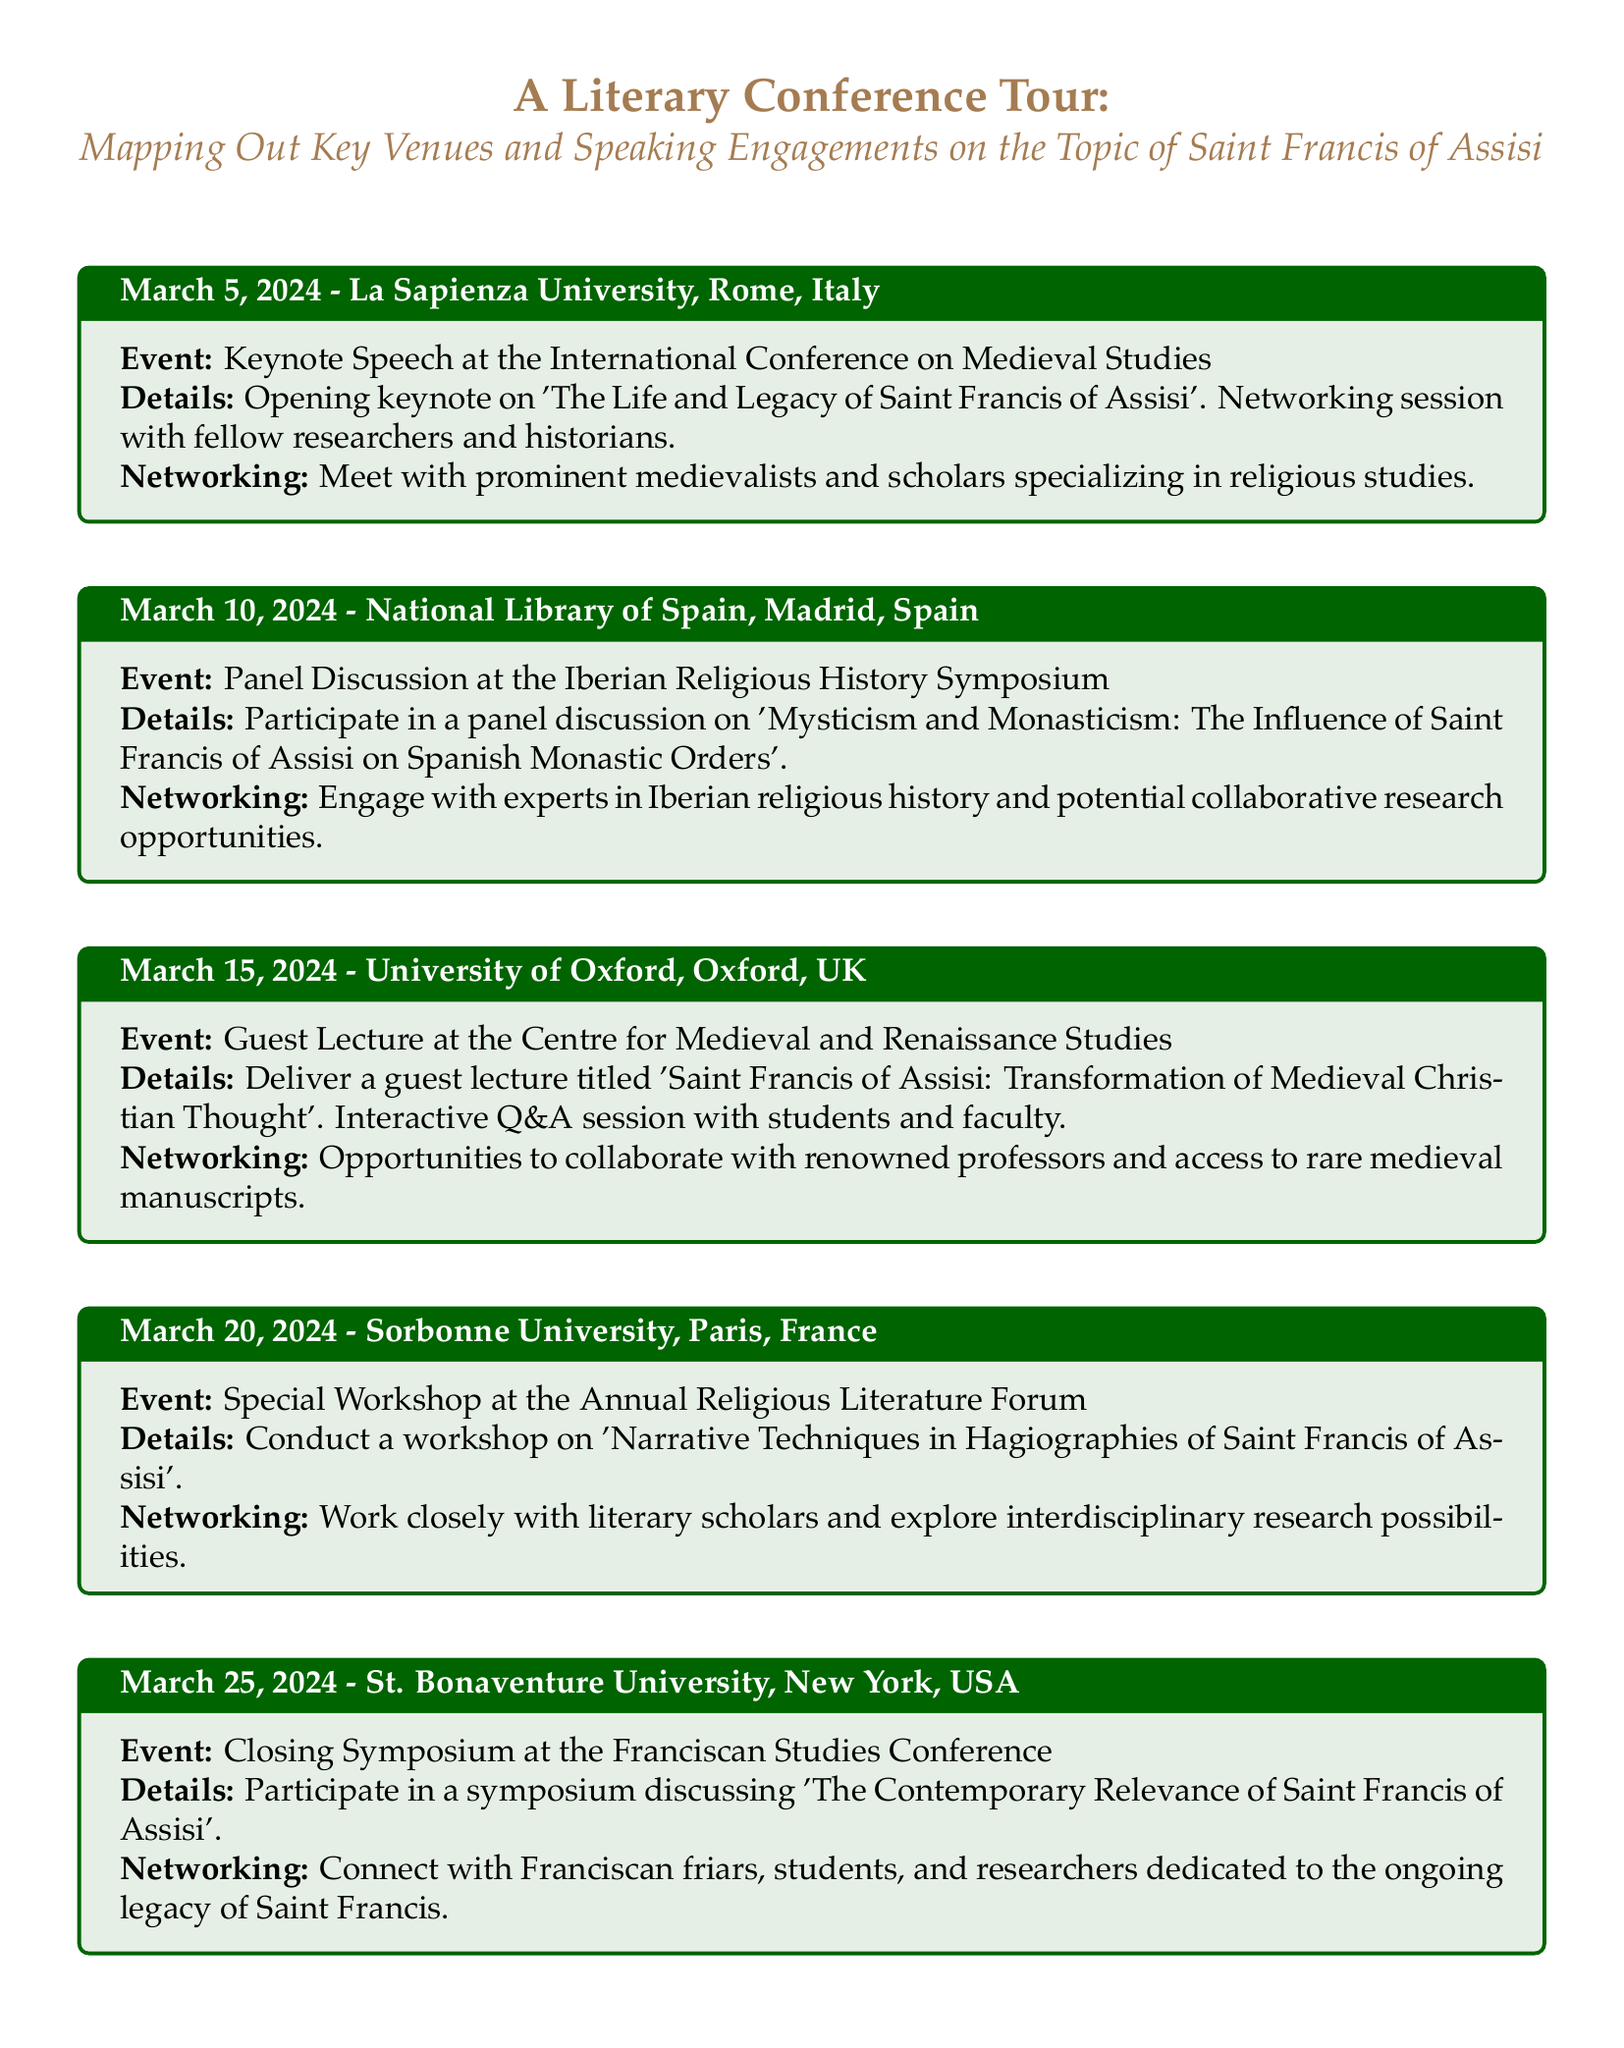What is the date of the keynote speech? The keynote speech takes place on March 5, 2024, at La Sapienza University in Rome, Italy.
Answer: March 5, 2024 What is the title of the guest lecture at the University of Oxford? The title of the guest lecture is 'Saint Francis of Assisi: Transformation of Medieval Christian Thought'.
Answer: Saint Francis of Assisi: Transformation of Medieval Christian Thought Where will the panel discussion on Iberian Religious History be held? The panel discussion will be held at the National Library of Spain in Madrid, Spain.
Answer: National Library of Spain, Madrid, Spain What is the focus of the workshop at Sorbonne University? The workshop focuses on 'Narrative Techniques in Hagiographies of Saint Francis of Assisi'.
Answer: Narrative Techniques in Hagiographies of Saint Francis of Assisi Which university will host the closing symposium? The closing symposium will be hosted at St. Bonaventure University in New York, USA.
Answer: St. Bonaventure University, New York, USA What is one opportunity for networking mentioned at the La Sapienza University event? At the La Sapienza University event, attendees have the opportunity to meet prominent medievalists and scholars specializing in religious studies.
Answer: Meet prominent medievalists and scholars What type of event happens on March 20, 2024? On March 20, 2024, a Special Workshop occurs at the Annual Religious Literature Forum.
Answer: Special Workshop Who will attendees connect with at the closing symposium? Attendees at the closing symposium will connect with Franciscan friars, students, and researchers.
Answer: Franciscan friars, students, and researchers What theme is explored in the symposium at St. Bonaventure University? The theme explored is 'The Contemporary Relevance of Saint Francis of Assisi'.
Answer: The Contemporary Relevance of Saint Francis of Assisi 